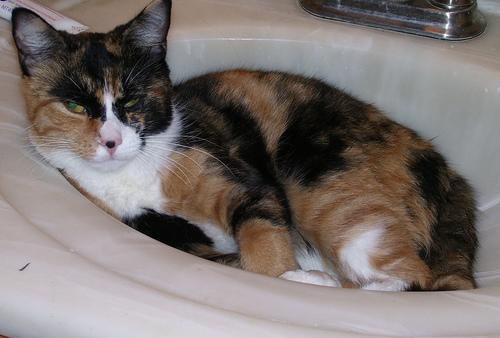How many colors does the cat have?
Be succinct. 3. How many animals are shown?
Keep it brief. 1. What color is the cat?
Answer briefly. Calico. Is the cats eyes closed?
Concise answer only. No. 